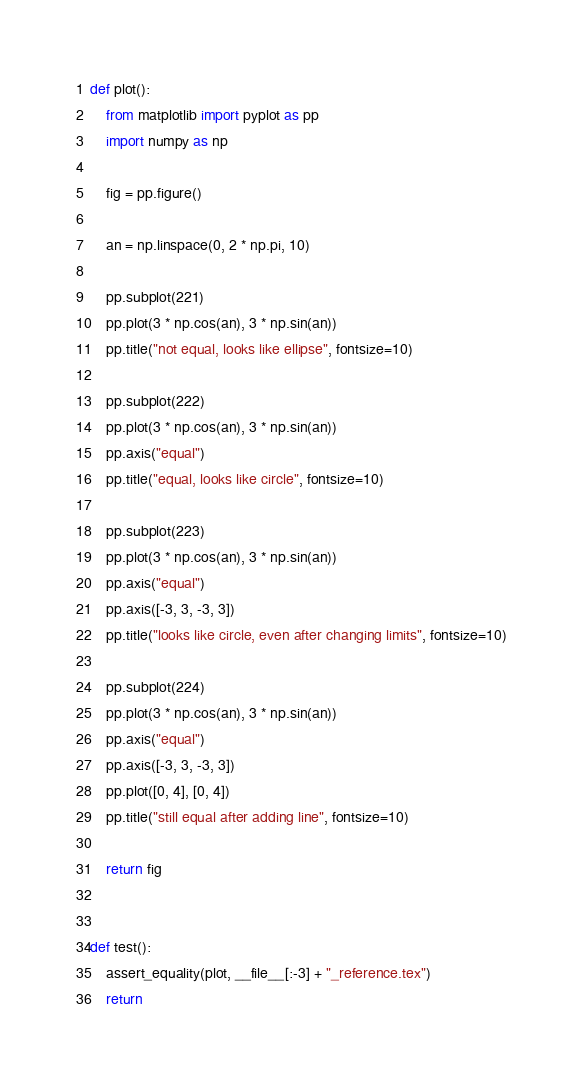Convert code to text. <code><loc_0><loc_0><loc_500><loc_500><_Python_>
def plot():
    from matplotlib import pyplot as pp
    import numpy as np

    fig = pp.figure()

    an = np.linspace(0, 2 * np.pi, 10)

    pp.subplot(221)
    pp.plot(3 * np.cos(an), 3 * np.sin(an))
    pp.title("not equal, looks like ellipse", fontsize=10)

    pp.subplot(222)
    pp.plot(3 * np.cos(an), 3 * np.sin(an))
    pp.axis("equal")
    pp.title("equal, looks like circle", fontsize=10)

    pp.subplot(223)
    pp.plot(3 * np.cos(an), 3 * np.sin(an))
    pp.axis("equal")
    pp.axis([-3, 3, -3, 3])
    pp.title("looks like circle, even after changing limits", fontsize=10)

    pp.subplot(224)
    pp.plot(3 * np.cos(an), 3 * np.sin(an))
    pp.axis("equal")
    pp.axis([-3, 3, -3, 3])
    pp.plot([0, 4], [0, 4])
    pp.title("still equal after adding line", fontsize=10)

    return fig


def test():
    assert_equality(plot, __file__[:-3] + "_reference.tex")
    return
</code> 